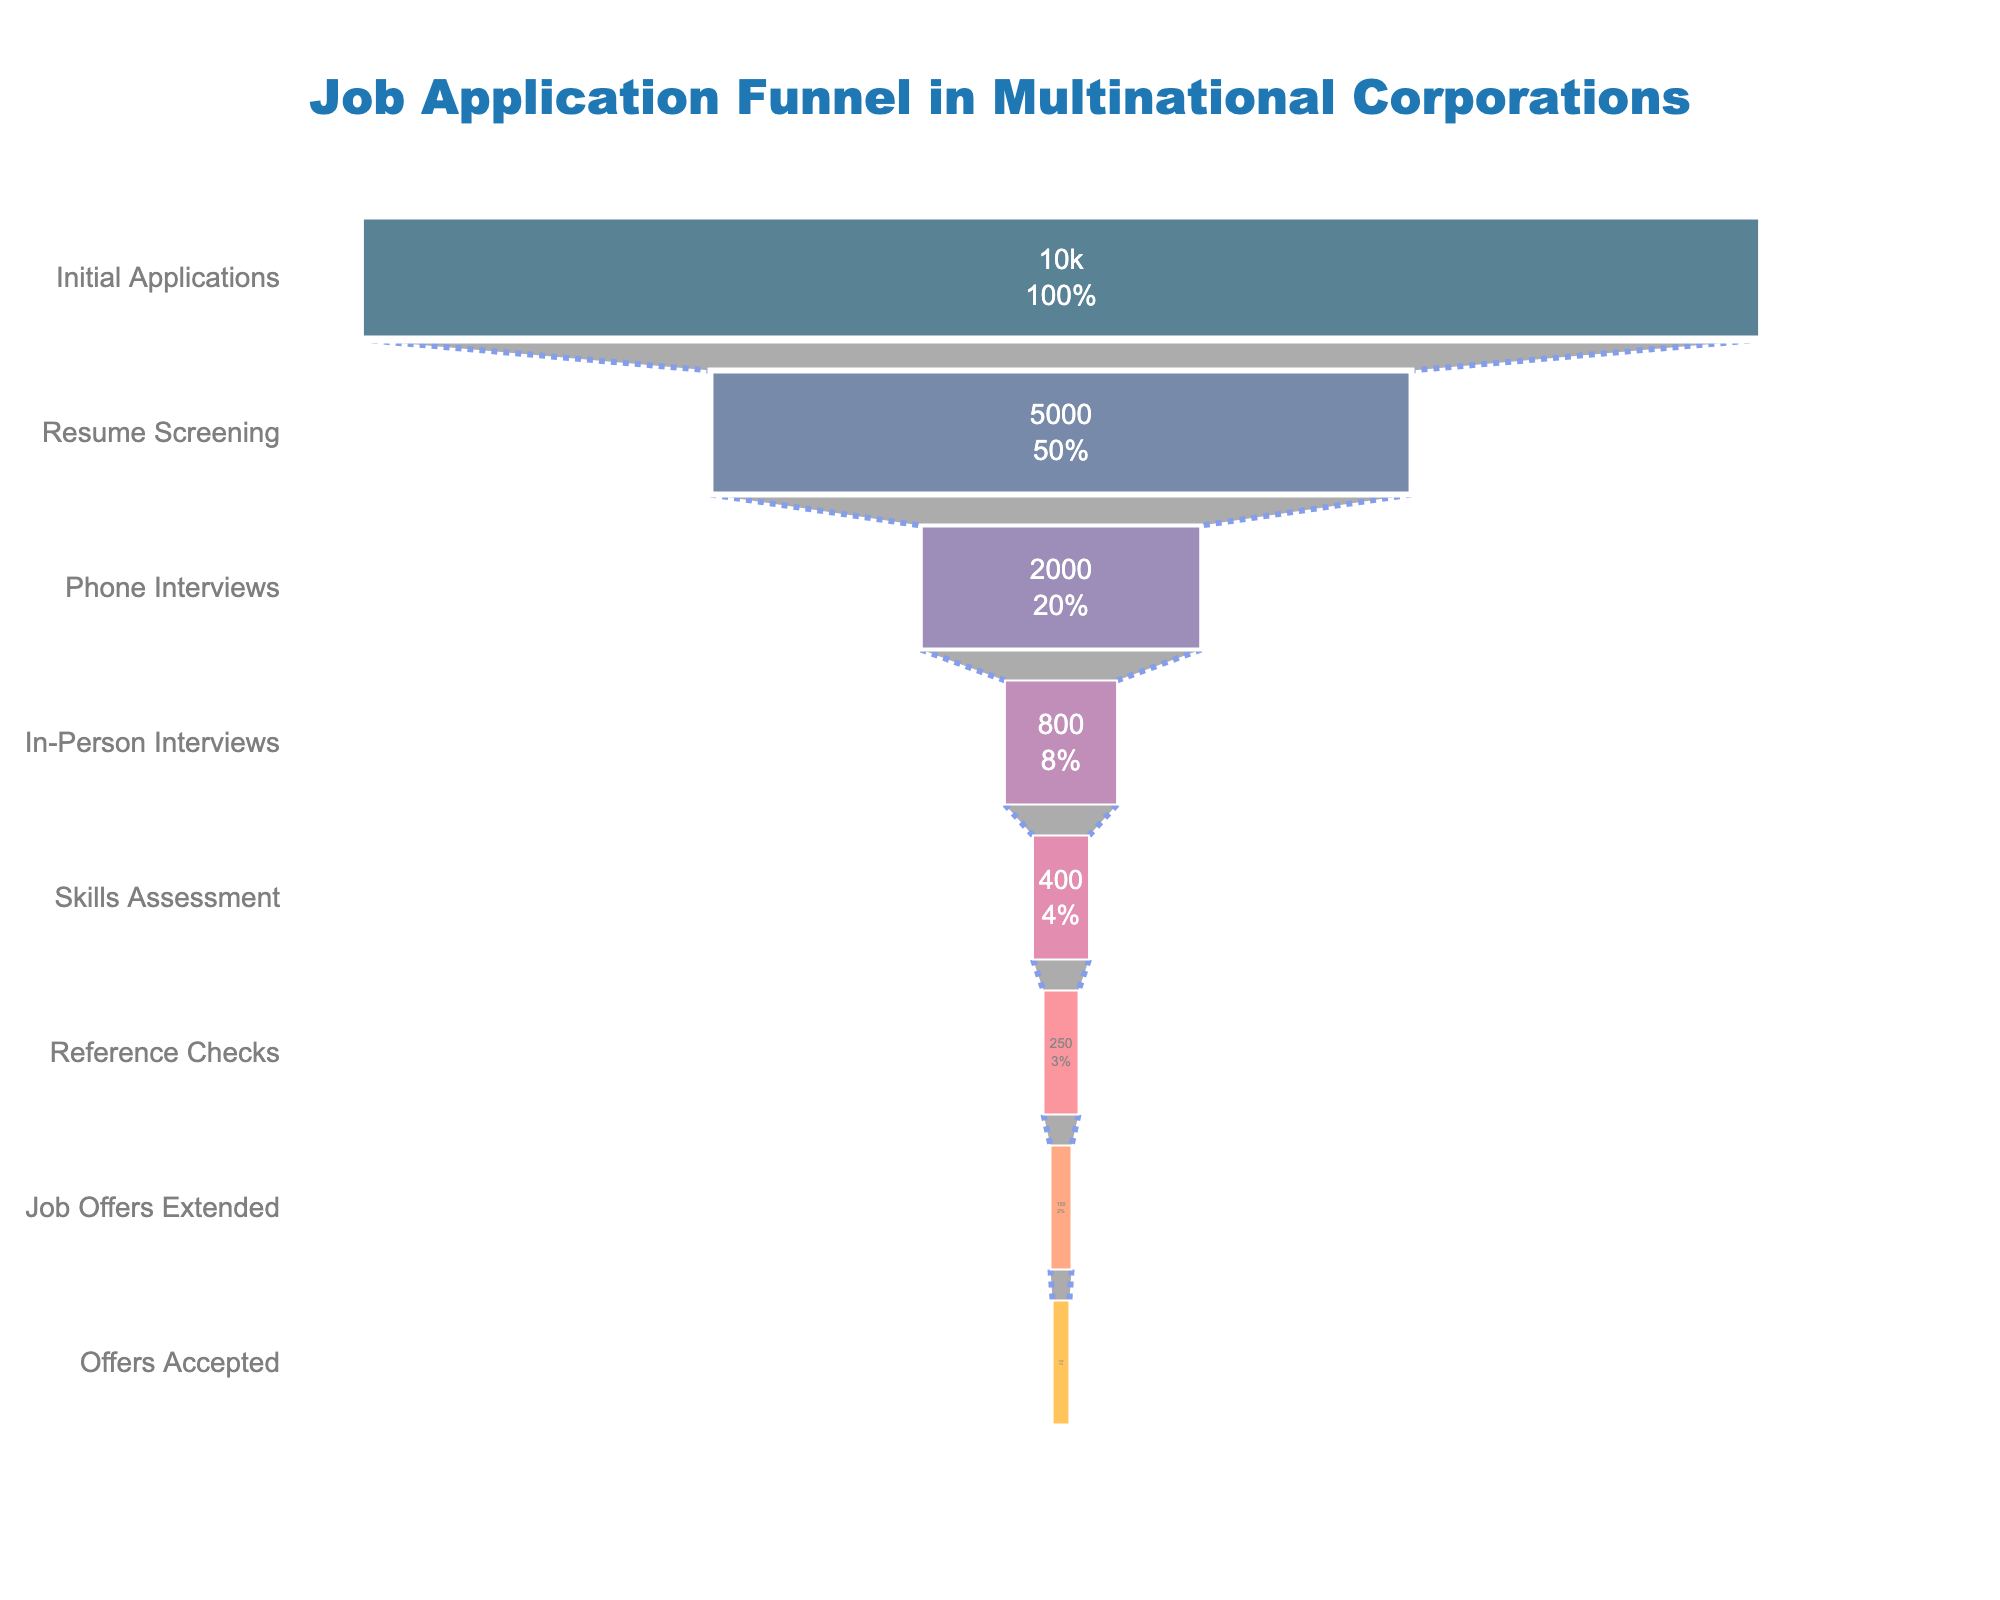What is the title of the funnel chart? The title of the chart is displayed prominently at the top and provides an overview of what the chart represents. In this case, it reads: "Job Application Funnel in Multinational Corporations".
Answer: Job Application Funnel in Multinational Corporations How many stages are depicted in the funnel chart? Count the number of distinct stages listed from top to bottom. Each label represents a different stage in the job application process.
Answer: 8 What is the percentage of applicants that make it to the Phone Interviews stage? The percentage of applicants at this stage is shown inside the funnel segment. It's calculated by dividing the number of applicants at this stage by the initial number of applicants and multiplying by 100.
Answer: 20% How many applicants were shortlisted for Skills Assessment? The number of applicants for each stage is explicitly stated within the funnel segment corresponding to that stage. For Skills Assessment, it is listed directly as 400.
Answer: 400 What is the difference in the number of applicants between the Resume Screening and Phone Interviews stages? Subtract the number of applicants in the Phone Interviews stage from the number of applicants in the Resume Screening stage. The calculation is 5000 - 2000.
Answer: 3000 Which stage sees the highest drop-off in the number of applicants? To determine this, compare the number of applicants at each stage and find the largest difference between consecutive stages. The biggest drop is from Resume Screening (5000) to Phone Interviews (2000).
Answer: Resume Screening to Phone Interviews What proportion of the initial applicants eventually accept job offers? Calculate this by dividing the number of offers accepted by the initial number of applicants and then converting to a percentage: (120/10000) * 100%.
Answer: 1.2% How many stages retain less than half of the initial applicants? Identify stages where the number of applicants is less than half of 10000, which is 5000. Count these stages.
Answer: 6 Compare the number of applicants in 'In-Person Interviews' versus 'Reference Checks'. Which stage has more applicants? Compare the figures for both stages directly from the chart: In-Person Interviews has 800 applicants while Reference Checks has 250. Therefore, 'In-Person Interviews' has more applicants.
Answer: In-Person Interviews What is the percentage decrease from the Skills Assessment stage to the Reference Checks stage? Calculate the percentage decrease by subtracting the applicants at the Reference Checks stage from those at the Skills Assessment stage, dividing by the Skills Assessment number, and then multiplying by 100: ((400-250)/400) * 100%.
Answer: 37.5% 